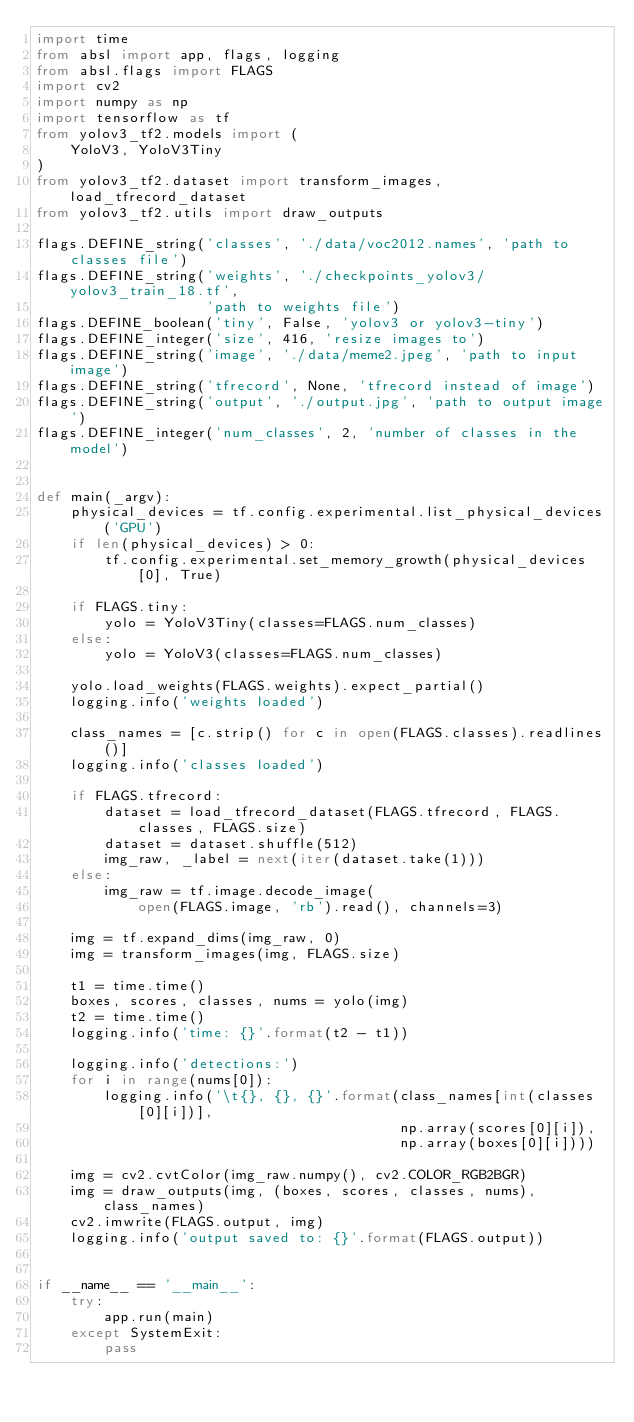Convert code to text. <code><loc_0><loc_0><loc_500><loc_500><_Python_>import time
from absl import app, flags, logging
from absl.flags import FLAGS
import cv2
import numpy as np
import tensorflow as tf
from yolov3_tf2.models import (
    YoloV3, YoloV3Tiny
)
from yolov3_tf2.dataset import transform_images, load_tfrecord_dataset
from yolov3_tf2.utils import draw_outputs

flags.DEFINE_string('classes', './data/voc2012.names', 'path to classes file')
flags.DEFINE_string('weights', './checkpoints_yolov3/yolov3_train_18.tf',
                    'path to weights file')
flags.DEFINE_boolean('tiny', False, 'yolov3 or yolov3-tiny')
flags.DEFINE_integer('size', 416, 'resize images to')
flags.DEFINE_string('image', './data/meme2.jpeg', 'path to input image')
flags.DEFINE_string('tfrecord', None, 'tfrecord instead of image')
flags.DEFINE_string('output', './output.jpg', 'path to output image')
flags.DEFINE_integer('num_classes', 2, 'number of classes in the model')


def main(_argv):
    physical_devices = tf.config.experimental.list_physical_devices('GPU')
    if len(physical_devices) > 0:
        tf.config.experimental.set_memory_growth(physical_devices[0], True)

    if FLAGS.tiny:
        yolo = YoloV3Tiny(classes=FLAGS.num_classes)
    else:
        yolo = YoloV3(classes=FLAGS.num_classes)

    yolo.load_weights(FLAGS.weights).expect_partial()
    logging.info('weights loaded')

    class_names = [c.strip() for c in open(FLAGS.classes).readlines()]
    logging.info('classes loaded')

    if FLAGS.tfrecord:
        dataset = load_tfrecord_dataset(FLAGS.tfrecord, FLAGS.classes, FLAGS.size)
        dataset = dataset.shuffle(512)
        img_raw, _label = next(iter(dataset.take(1)))
    else:
        img_raw = tf.image.decode_image(
            open(FLAGS.image, 'rb').read(), channels=3)

    img = tf.expand_dims(img_raw, 0)
    img = transform_images(img, FLAGS.size)

    t1 = time.time()
    boxes, scores, classes, nums = yolo(img)
    t2 = time.time()
    logging.info('time: {}'.format(t2 - t1))

    logging.info('detections:')
    for i in range(nums[0]):
        logging.info('\t{}, {}, {}'.format(class_names[int(classes[0][i])],
                                           np.array(scores[0][i]),
                                           np.array(boxes[0][i])))

    img = cv2.cvtColor(img_raw.numpy(), cv2.COLOR_RGB2BGR)
    img = draw_outputs(img, (boxes, scores, classes, nums), class_names)
    cv2.imwrite(FLAGS.output, img)
    logging.info('output saved to: {}'.format(FLAGS.output))


if __name__ == '__main__':
    try:
        app.run(main)
    except SystemExit:
        pass
</code> 